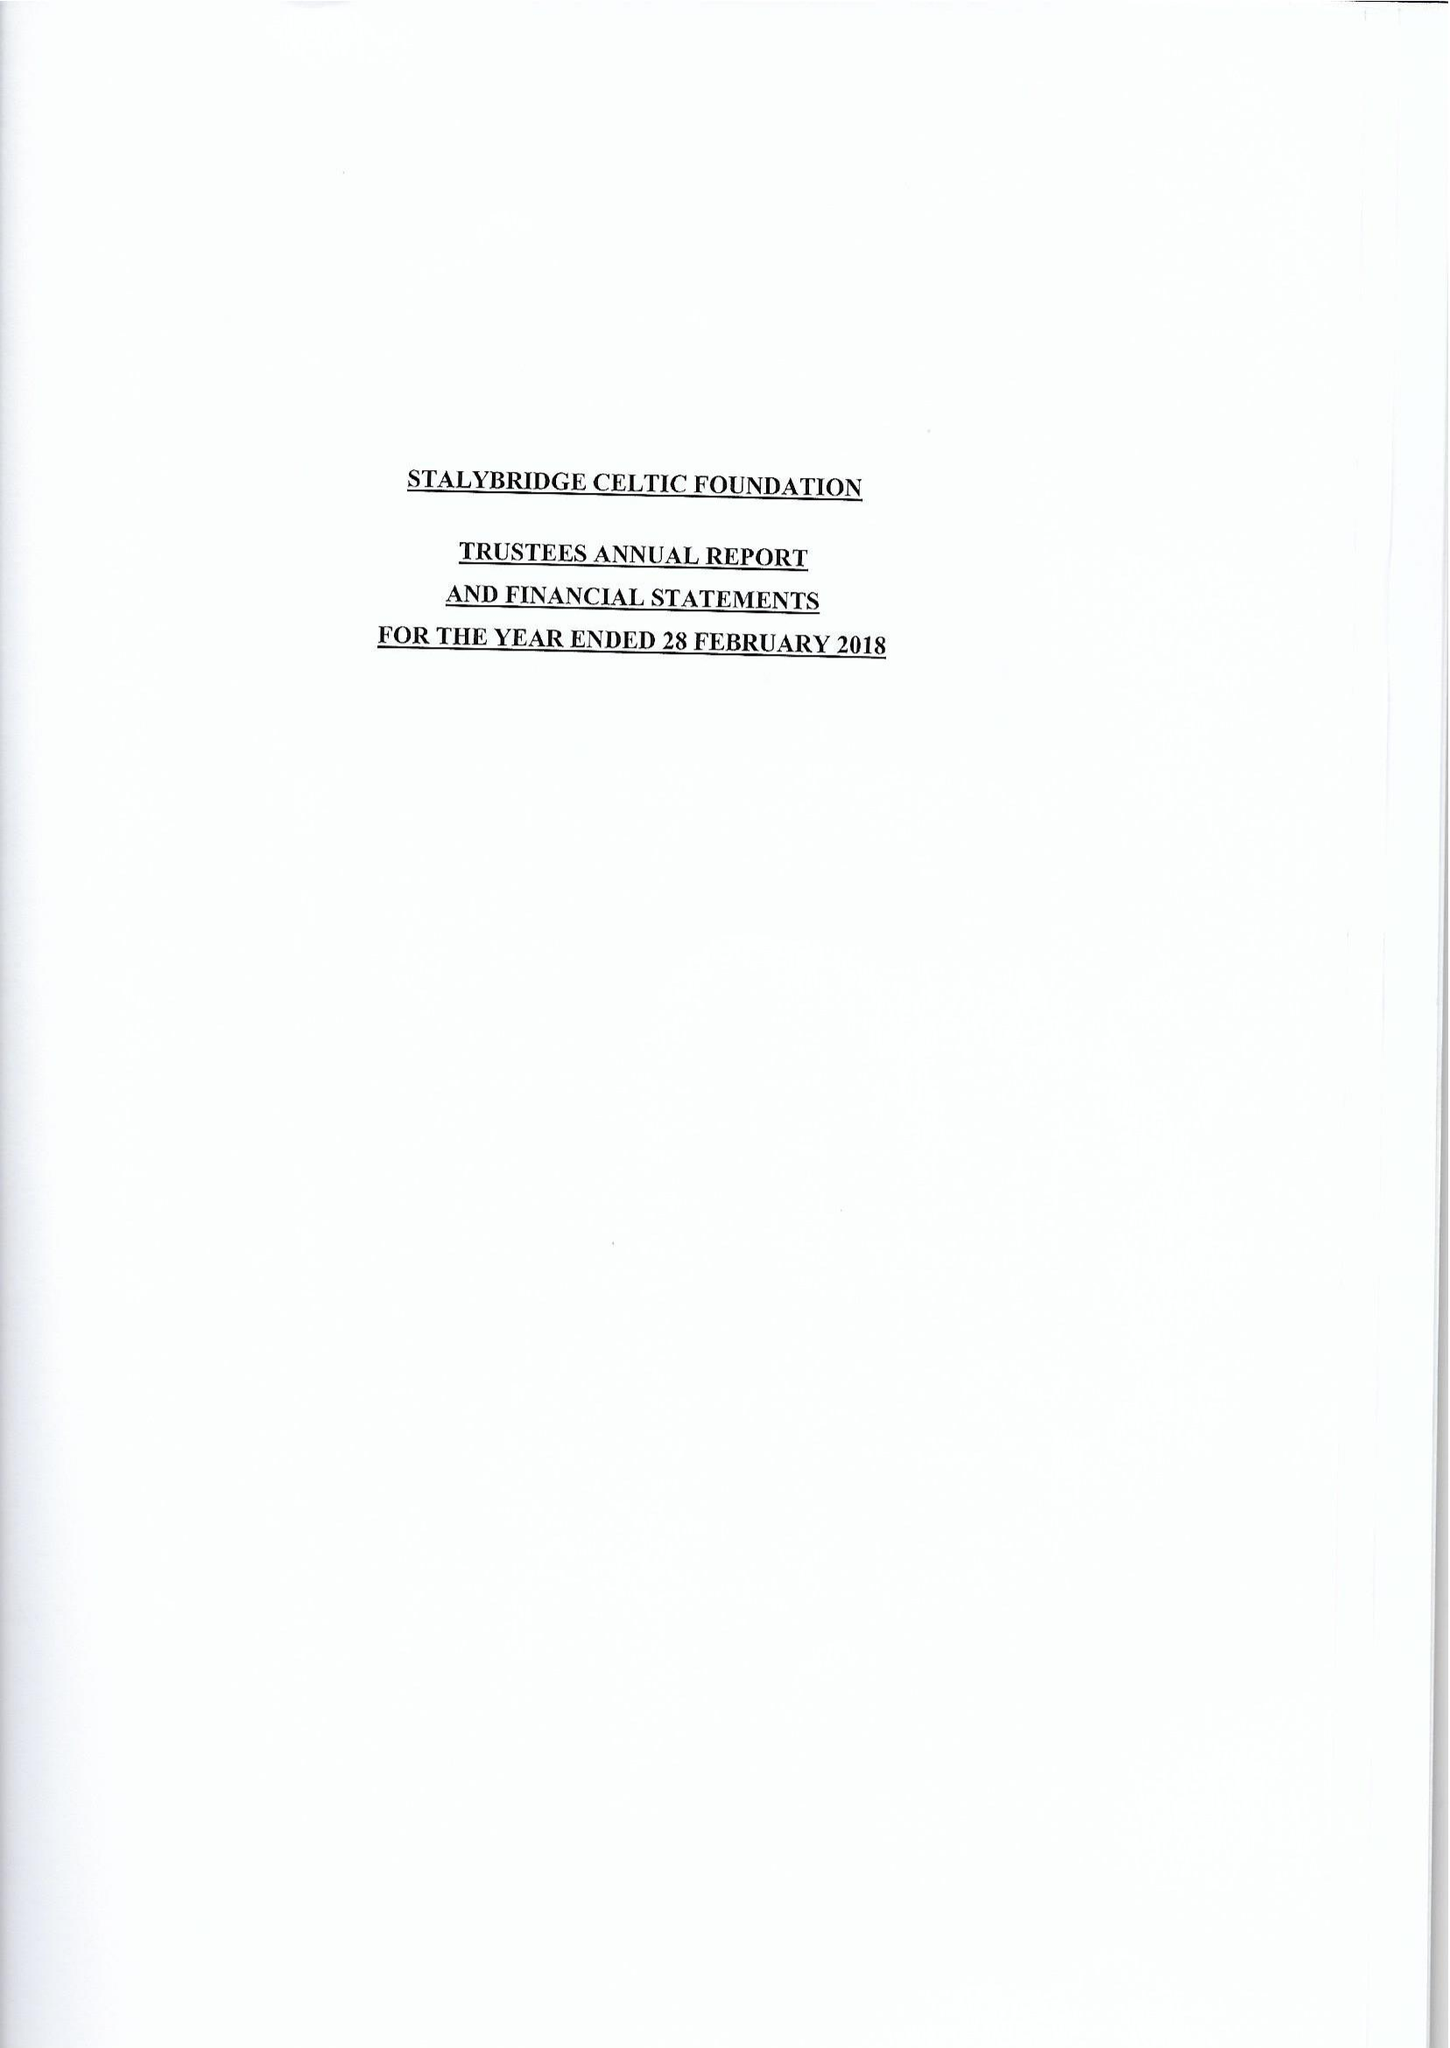What is the value for the address__post_town?
Answer the question using a single word or phrase. STALYBRIDGE 